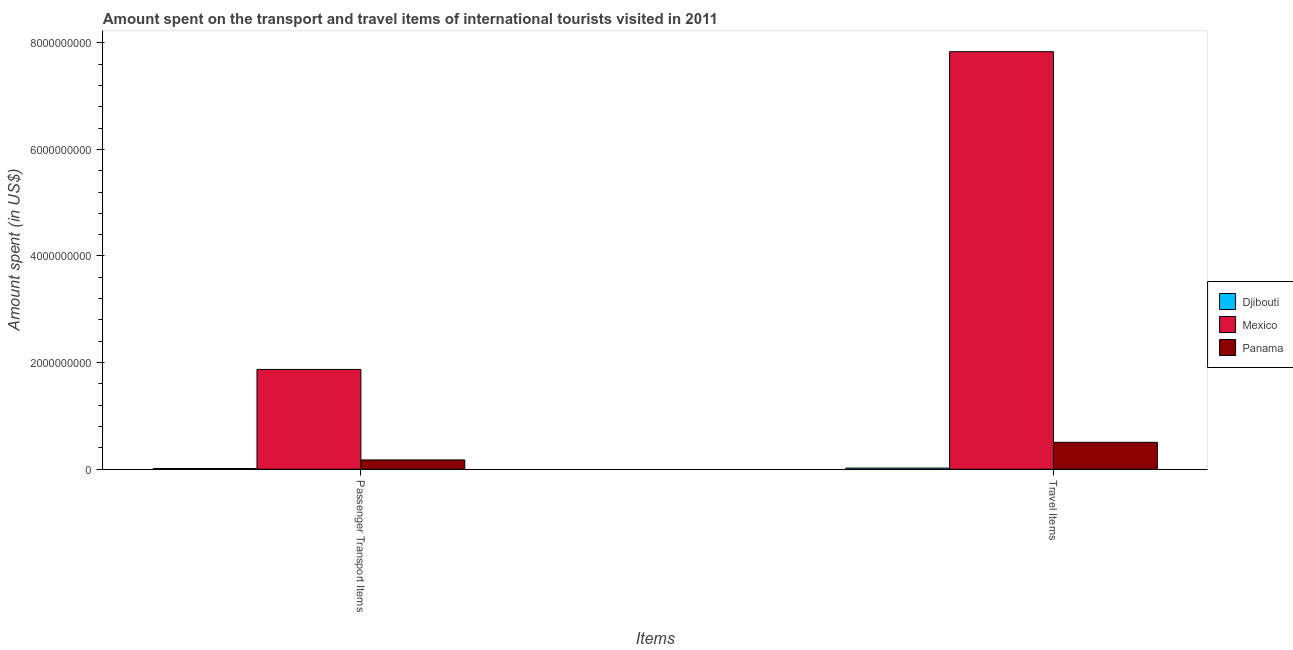How many groups of bars are there?
Give a very brief answer. 2. Are the number of bars per tick equal to the number of legend labels?
Your answer should be very brief. Yes. Are the number of bars on each tick of the X-axis equal?
Provide a short and direct response. Yes. How many bars are there on the 2nd tick from the left?
Keep it short and to the point. 3. What is the label of the 1st group of bars from the left?
Give a very brief answer. Passenger Transport Items. What is the amount spent on passenger transport items in Mexico?
Make the answer very short. 1.87e+09. Across all countries, what is the maximum amount spent on passenger transport items?
Make the answer very short. 1.87e+09. Across all countries, what is the minimum amount spent in travel items?
Give a very brief answer. 2.10e+07. In which country was the amount spent on passenger transport items maximum?
Give a very brief answer. Mexico. In which country was the amount spent in travel items minimum?
Ensure brevity in your answer.  Djibouti. What is the total amount spent in travel items in the graph?
Provide a short and direct response. 8.36e+09. What is the difference between the amount spent on passenger transport items in Mexico and that in Djibouti?
Make the answer very short. 1.86e+09. What is the difference between the amount spent in travel items in Panama and the amount spent on passenger transport items in Mexico?
Your response must be concise. -1.37e+09. What is the average amount spent on passenger transport items per country?
Ensure brevity in your answer.  6.86e+08. What is the difference between the amount spent in travel items and amount spent on passenger transport items in Djibouti?
Your response must be concise. 8.50e+06. In how many countries, is the amount spent on passenger transport items greater than 7600000000 US$?
Ensure brevity in your answer.  0. What is the ratio of the amount spent in travel items in Panama to that in Mexico?
Your response must be concise. 0.06. What does the 2nd bar from the left in Passenger Transport Items represents?
Offer a very short reply. Mexico. What does the 1st bar from the right in Travel Items represents?
Make the answer very short. Panama. How many bars are there?
Ensure brevity in your answer.  6. Are all the bars in the graph horizontal?
Your response must be concise. No. Where does the legend appear in the graph?
Your answer should be very brief. Center right. How many legend labels are there?
Your response must be concise. 3. What is the title of the graph?
Offer a terse response. Amount spent on the transport and travel items of international tourists visited in 2011. Does "Curacao" appear as one of the legend labels in the graph?
Provide a succinct answer. No. What is the label or title of the X-axis?
Offer a very short reply. Items. What is the label or title of the Y-axis?
Offer a very short reply. Amount spent (in US$). What is the Amount spent (in US$) in Djibouti in Passenger Transport Items?
Provide a short and direct response. 1.25e+07. What is the Amount spent (in US$) of Mexico in Passenger Transport Items?
Offer a very short reply. 1.87e+09. What is the Amount spent (in US$) of Panama in Passenger Transport Items?
Your answer should be compact. 1.74e+08. What is the Amount spent (in US$) of Djibouti in Travel Items?
Keep it short and to the point. 2.10e+07. What is the Amount spent (in US$) of Mexico in Travel Items?
Ensure brevity in your answer.  7.83e+09. What is the Amount spent (in US$) of Panama in Travel Items?
Give a very brief answer. 5.05e+08. Across all Items, what is the maximum Amount spent (in US$) of Djibouti?
Keep it short and to the point. 2.10e+07. Across all Items, what is the maximum Amount spent (in US$) of Mexico?
Your answer should be compact. 7.83e+09. Across all Items, what is the maximum Amount spent (in US$) of Panama?
Provide a short and direct response. 5.05e+08. Across all Items, what is the minimum Amount spent (in US$) in Djibouti?
Provide a succinct answer. 1.25e+07. Across all Items, what is the minimum Amount spent (in US$) in Mexico?
Offer a terse response. 1.87e+09. Across all Items, what is the minimum Amount spent (in US$) of Panama?
Make the answer very short. 1.74e+08. What is the total Amount spent (in US$) in Djibouti in the graph?
Make the answer very short. 3.35e+07. What is the total Amount spent (in US$) of Mexico in the graph?
Keep it short and to the point. 9.70e+09. What is the total Amount spent (in US$) of Panama in the graph?
Provide a short and direct response. 6.79e+08. What is the difference between the Amount spent (in US$) of Djibouti in Passenger Transport Items and that in Travel Items?
Your answer should be compact. -8.50e+06. What is the difference between the Amount spent (in US$) in Mexico in Passenger Transport Items and that in Travel Items?
Ensure brevity in your answer.  -5.96e+09. What is the difference between the Amount spent (in US$) in Panama in Passenger Transport Items and that in Travel Items?
Offer a terse response. -3.31e+08. What is the difference between the Amount spent (in US$) of Djibouti in Passenger Transport Items and the Amount spent (in US$) of Mexico in Travel Items?
Your answer should be very brief. -7.82e+09. What is the difference between the Amount spent (in US$) of Djibouti in Passenger Transport Items and the Amount spent (in US$) of Panama in Travel Items?
Your answer should be compact. -4.92e+08. What is the difference between the Amount spent (in US$) in Mexico in Passenger Transport Items and the Amount spent (in US$) in Panama in Travel Items?
Keep it short and to the point. 1.37e+09. What is the average Amount spent (in US$) of Djibouti per Items?
Provide a short and direct response. 1.68e+07. What is the average Amount spent (in US$) in Mexico per Items?
Ensure brevity in your answer.  4.85e+09. What is the average Amount spent (in US$) in Panama per Items?
Make the answer very short. 3.40e+08. What is the difference between the Amount spent (in US$) of Djibouti and Amount spent (in US$) of Mexico in Passenger Transport Items?
Offer a terse response. -1.86e+09. What is the difference between the Amount spent (in US$) in Djibouti and Amount spent (in US$) in Panama in Passenger Transport Items?
Offer a very short reply. -1.62e+08. What is the difference between the Amount spent (in US$) in Mexico and Amount spent (in US$) in Panama in Passenger Transport Items?
Provide a short and direct response. 1.70e+09. What is the difference between the Amount spent (in US$) in Djibouti and Amount spent (in US$) in Mexico in Travel Items?
Make the answer very short. -7.81e+09. What is the difference between the Amount spent (in US$) in Djibouti and Amount spent (in US$) in Panama in Travel Items?
Offer a terse response. -4.84e+08. What is the difference between the Amount spent (in US$) in Mexico and Amount spent (in US$) in Panama in Travel Items?
Offer a terse response. 7.33e+09. What is the ratio of the Amount spent (in US$) of Djibouti in Passenger Transport Items to that in Travel Items?
Keep it short and to the point. 0.6. What is the ratio of the Amount spent (in US$) in Mexico in Passenger Transport Items to that in Travel Items?
Offer a terse response. 0.24. What is the ratio of the Amount spent (in US$) in Panama in Passenger Transport Items to that in Travel Items?
Your response must be concise. 0.34. What is the difference between the highest and the second highest Amount spent (in US$) of Djibouti?
Make the answer very short. 8.50e+06. What is the difference between the highest and the second highest Amount spent (in US$) in Mexico?
Ensure brevity in your answer.  5.96e+09. What is the difference between the highest and the second highest Amount spent (in US$) in Panama?
Give a very brief answer. 3.31e+08. What is the difference between the highest and the lowest Amount spent (in US$) in Djibouti?
Your answer should be very brief. 8.50e+06. What is the difference between the highest and the lowest Amount spent (in US$) in Mexico?
Ensure brevity in your answer.  5.96e+09. What is the difference between the highest and the lowest Amount spent (in US$) of Panama?
Ensure brevity in your answer.  3.31e+08. 